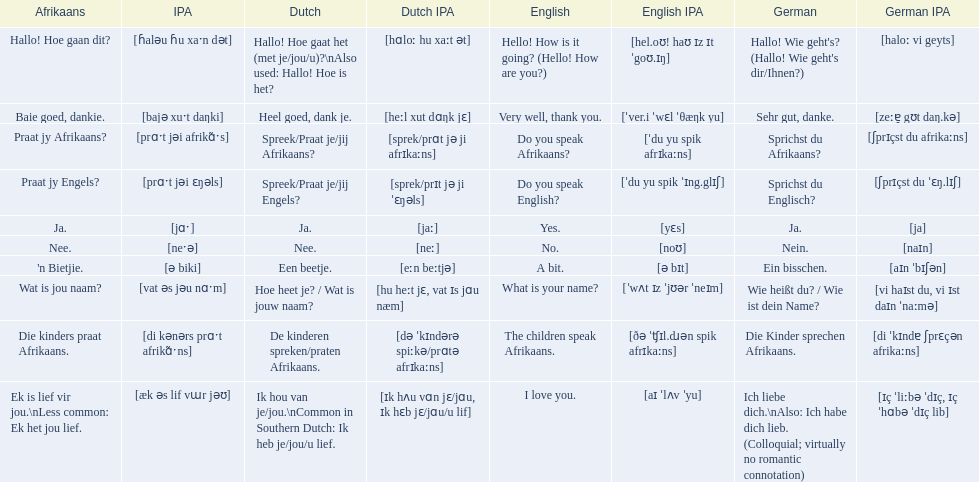What are the listed afrikaans phrases? Hallo! Hoe gaan dit?, Baie goed, dankie., Praat jy Afrikaans?, Praat jy Engels?, Ja., Nee., 'n Bietjie., Wat is jou naam?, Die kinders praat Afrikaans., Ek is lief vir jou.\nLess common: Ek het jou lief. Which is die kinders praat afrikaans? Die kinders praat Afrikaans. What is its german translation? Die Kinder sprechen Afrikaans. 